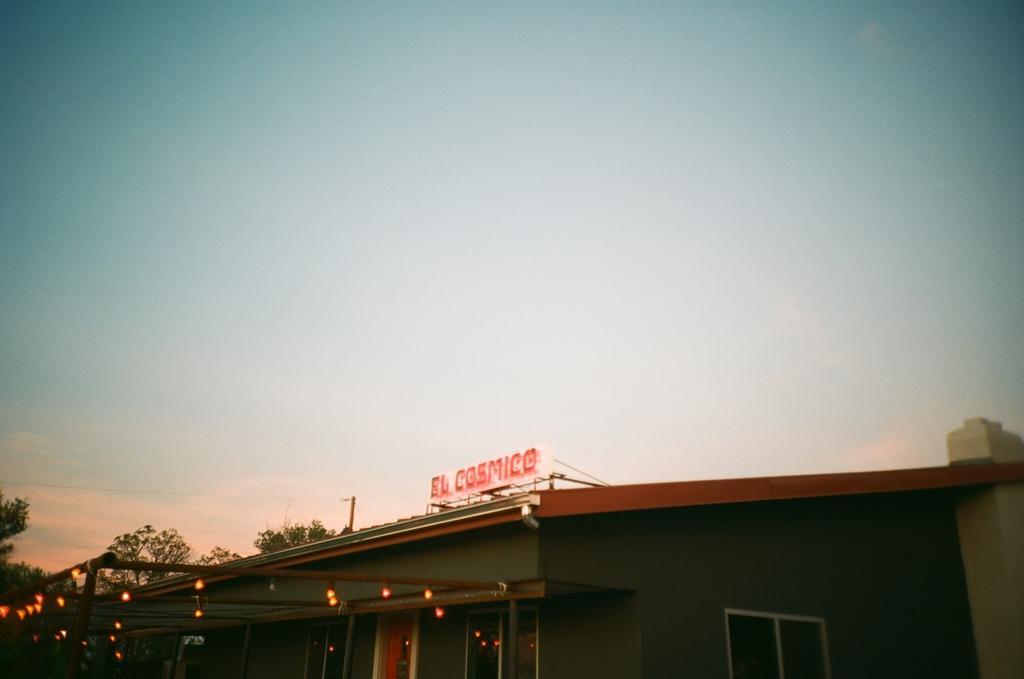Please provide a concise description of this image. In this picture we can see a building and few lights are visible on the poles. There are few trees in the background. Sky is blue in color. 